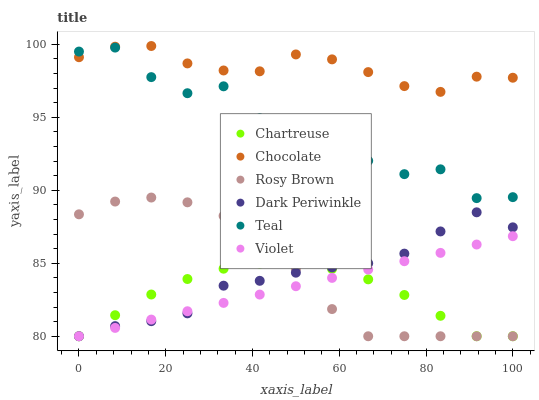Does Chartreuse have the minimum area under the curve?
Answer yes or no. Yes. Does Chocolate have the maximum area under the curve?
Answer yes or no. Yes. Does Chocolate have the minimum area under the curve?
Answer yes or no. No. Does Chartreuse have the maximum area under the curve?
Answer yes or no. No. Is Violet the smoothest?
Answer yes or no. Yes. Is Teal the roughest?
Answer yes or no. Yes. Is Chocolate the smoothest?
Answer yes or no. No. Is Chocolate the roughest?
Answer yes or no. No. Does Rosy Brown have the lowest value?
Answer yes or no. Yes. Does Chocolate have the lowest value?
Answer yes or no. No. Does Chocolate have the highest value?
Answer yes or no. Yes. Does Chartreuse have the highest value?
Answer yes or no. No. Is Violet less than Teal?
Answer yes or no. Yes. Is Chocolate greater than Rosy Brown?
Answer yes or no. Yes. Does Violet intersect Dark Periwinkle?
Answer yes or no. Yes. Is Violet less than Dark Periwinkle?
Answer yes or no. No. Is Violet greater than Dark Periwinkle?
Answer yes or no. No. Does Violet intersect Teal?
Answer yes or no. No. 